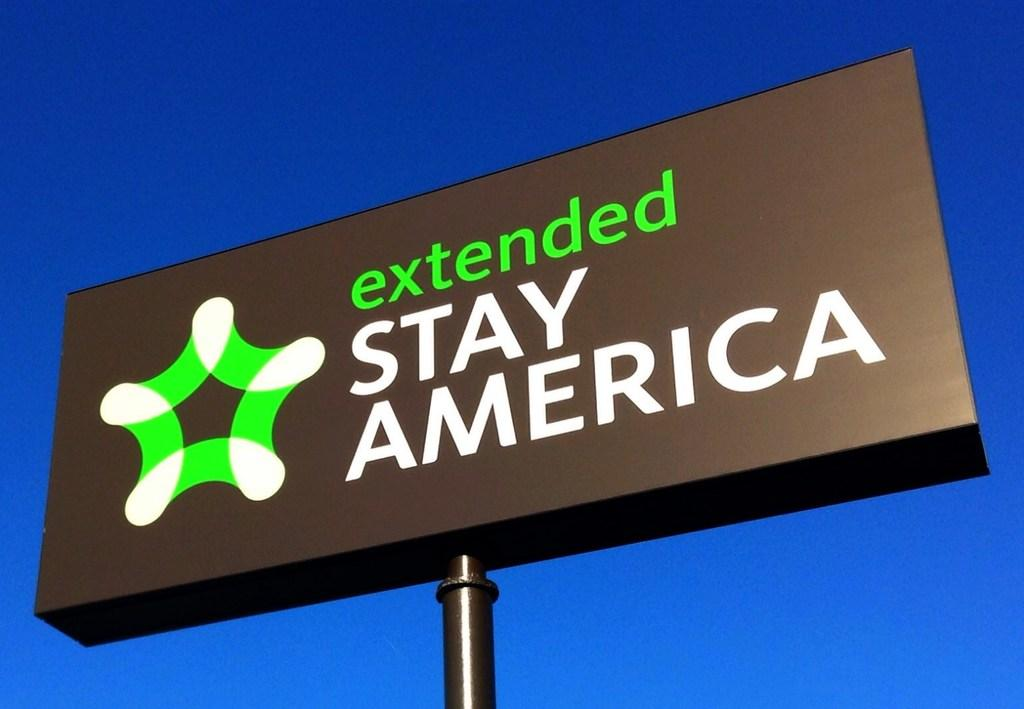<image>
Create a compact narrative representing the image presented. A tall black that has the words extended stay America on it.sign. 